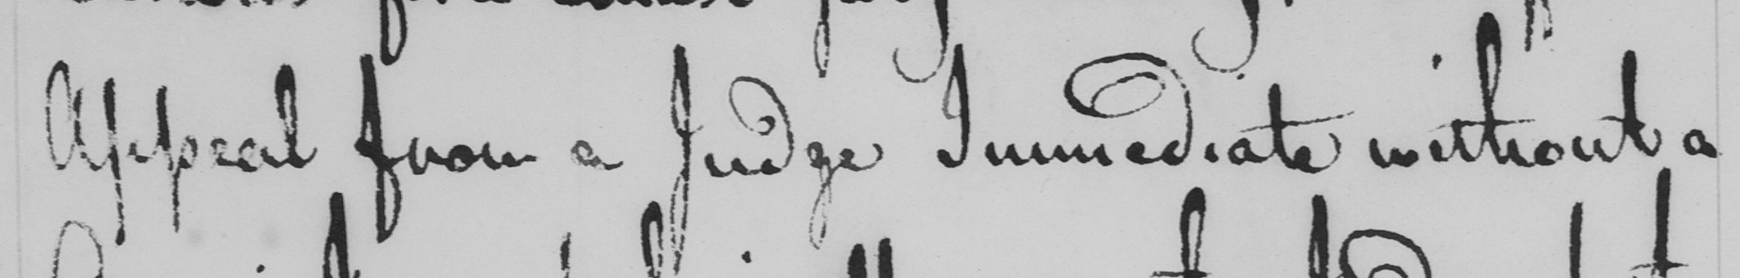Transcribe the text shown in this historical manuscript line. Appeal from a Judge Immediate without a 